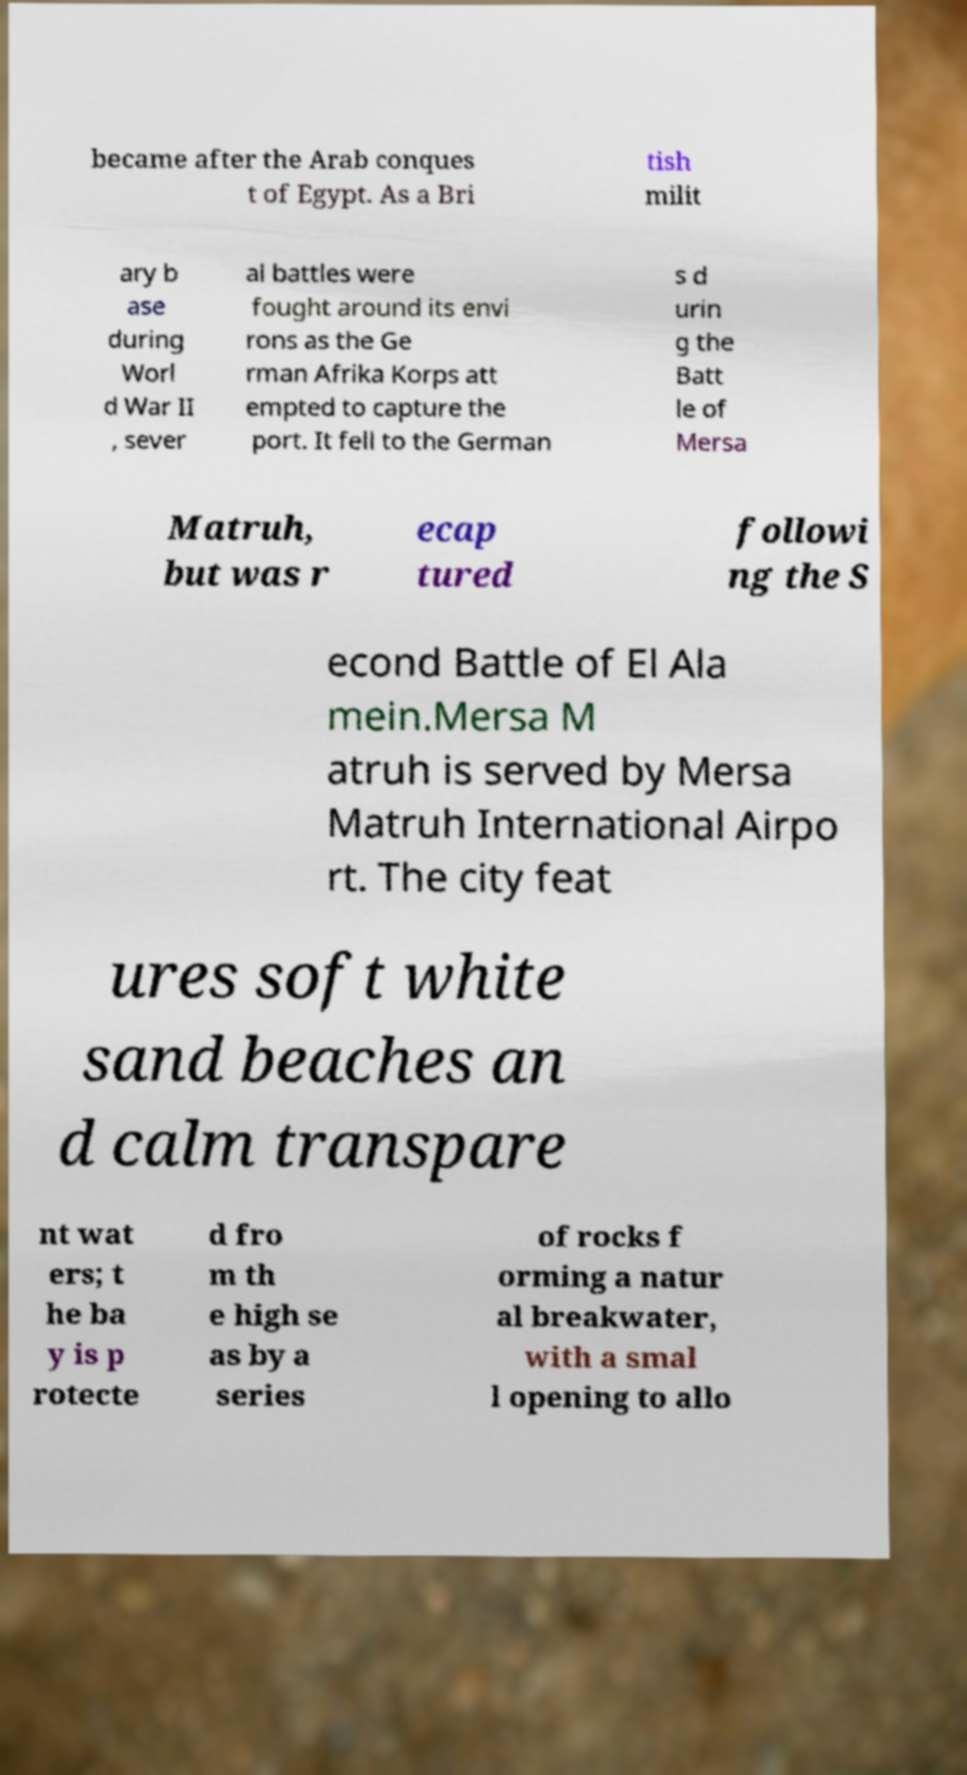For documentation purposes, I need the text within this image transcribed. Could you provide that? became after the Arab conques t of Egypt. As a Bri tish milit ary b ase during Worl d War II , sever al battles were fought around its envi rons as the Ge rman Afrika Korps att empted to capture the port. It fell to the German s d urin g the Batt le of Mersa Matruh, but was r ecap tured followi ng the S econd Battle of El Ala mein.Mersa M atruh is served by Mersa Matruh International Airpo rt. The city feat ures soft white sand beaches an d calm transpare nt wat ers; t he ba y is p rotecte d fro m th e high se as by a series of rocks f orming a natur al breakwater, with a smal l opening to allo 